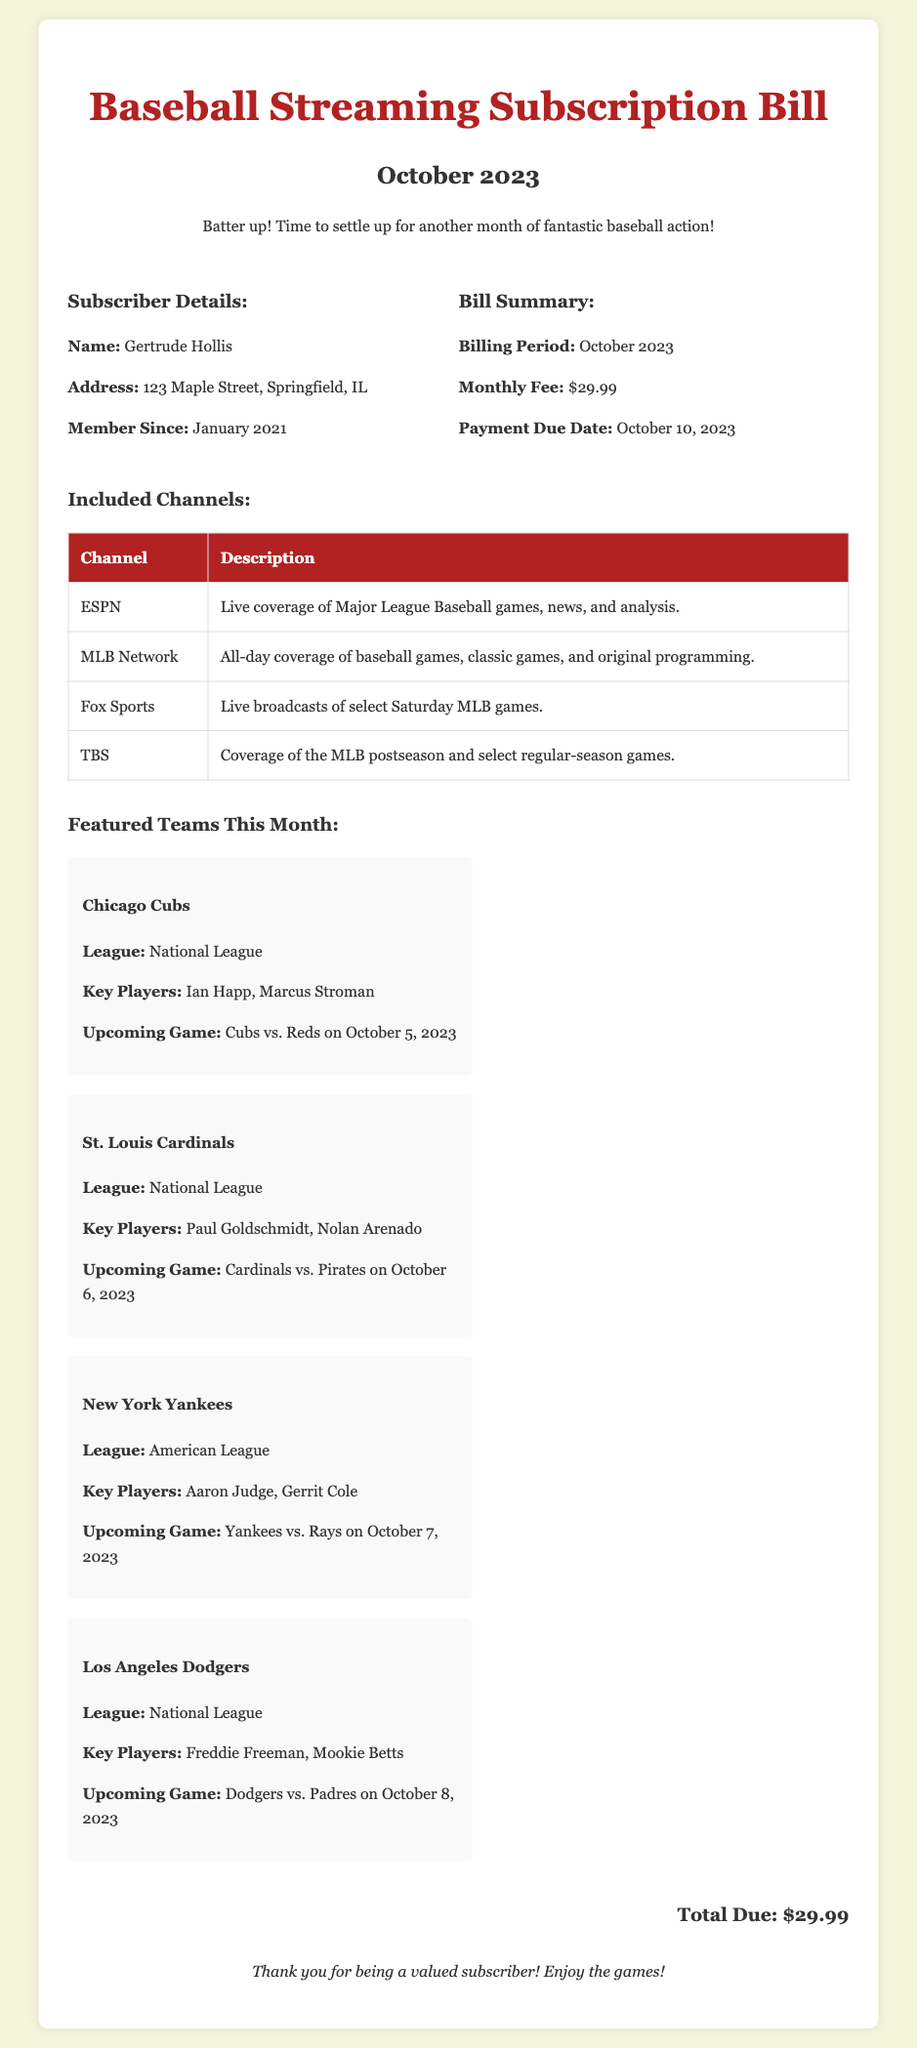What is the subscriber's name? The document provides the subscriber's name, which is Gertrude Hollis.
Answer: Gertrude Hollis What is the monthly fee? The bill summary indicates that the monthly fee is $29.99.
Answer: $29.99 What is the payment due date? The payment due date listed in the document is October 10, 2023.
Answer: October 10, 2023 Which team is featured first? The document lists the featured teams, starting with the Chicago Cubs.
Answer: Chicago Cubs Who are the key players for the New York Yankees? The document specifies that the key players for the Yankees are Aaron Judge and Gerrit Cole.
Answer: Aaron Judge, Gerrit Cole What channels are included in the subscription? The table of included channels shows ESPN, MLB Network, Fox Sports, and TBS.
Answer: ESPN, MLB Network, Fox Sports, TBS When did Gertrude become a member? The document states that Gertrude has been a member since January 2021.
Answer: January 2021 What is the total amount due? The total due at the end of the document confirms that it's $29.99.
Answer: $29.99 What is the upcoming game for the Los Angeles Dodgers? The document mentions that the Dodgers are scheduled to play against the Padres on October 8, 2023.
Answer: Dodgers vs. Padres on October 8, 2023 